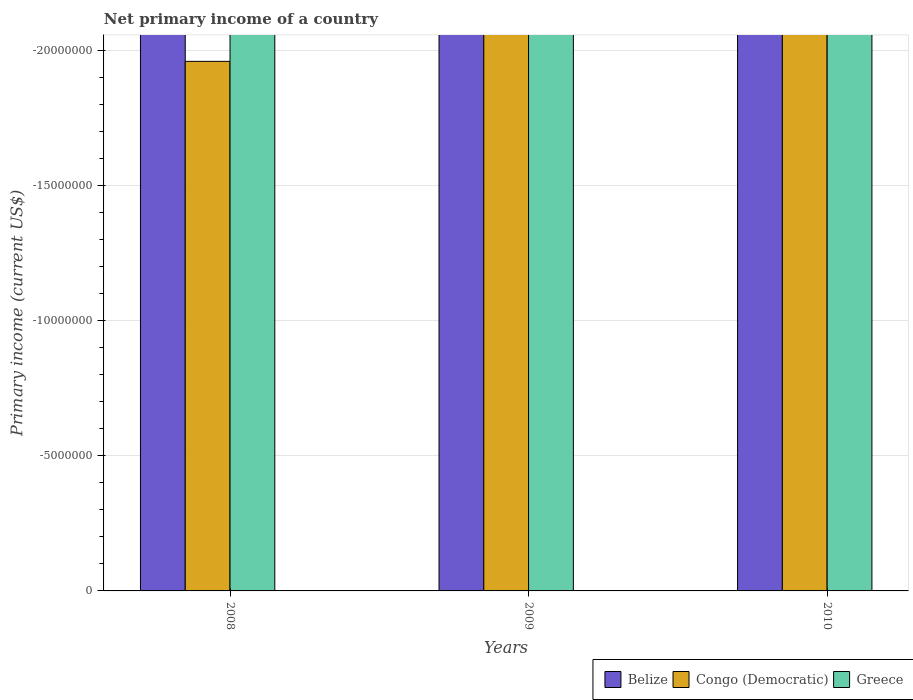How many different coloured bars are there?
Offer a terse response. 0. Are the number of bars per tick equal to the number of legend labels?
Your answer should be very brief. No. Are the number of bars on each tick of the X-axis equal?
Make the answer very short. Yes. How many bars are there on the 2nd tick from the left?
Give a very brief answer. 0. How many bars are there on the 1st tick from the right?
Offer a very short reply. 0. What is the primary income in Belize in 2010?
Make the answer very short. 0. In how many years, is the primary income in Greece greater than the average primary income in Greece taken over all years?
Offer a very short reply. 0. Is it the case that in every year, the sum of the primary income in Greece and primary income in Congo (Democratic) is greater than the primary income in Belize?
Keep it short and to the point. No. How many bars are there?
Your answer should be very brief. 0. Are all the bars in the graph horizontal?
Your answer should be compact. No. Are the values on the major ticks of Y-axis written in scientific E-notation?
Provide a succinct answer. No. Where does the legend appear in the graph?
Offer a terse response. Bottom right. How many legend labels are there?
Your response must be concise. 3. What is the title of the graph?
Make the answer very short. Net primary income of a country. What is the label or title of the Y-axis?
Your answer should be compact. Primary income (current US$). What is the Primary income (current US$) of Belize in 2008?
Give a very brief answer. 0. What is the Primary income (current US$) of Congo (Democratic) in 2008?
Offer a terse response. 0. What is the Primary income (current US$) of Congo (Democratic) in 2009?
Your answer should be very brief. 0. What is the Primary income (current US$) in Congo (Democratic) in 2010?
Offer a very short reply. 0. What is the Primary income (current US$) of Greece in 2010?
Give a very brief answer. 0. What is the total Primary income (current US$) in Congo (Democratic) in the graph?
Provide a succinct answer. 0. What is the total Primary income (current US$) in Greece in the graph?
Make the answer very short. 0. 